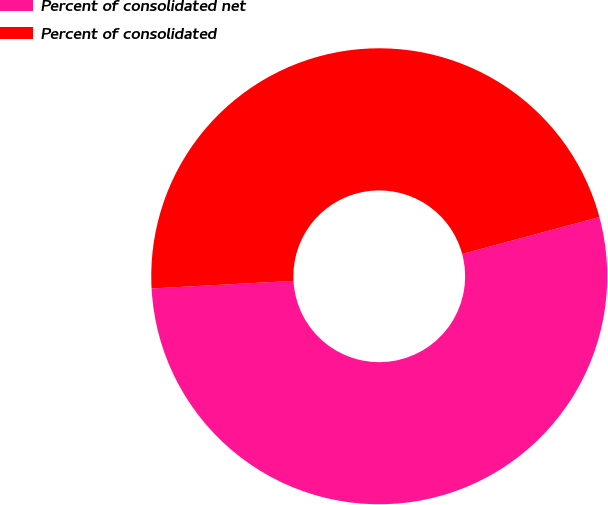Convert chart. <chart><loc_0><loc_0><loc_500><loc_500><pie_chart><fcel>Percent of consolidated net<fcel>Percent of consolidated<nl><fcel>53.33%<fcel>46.67%<nl></chart> 